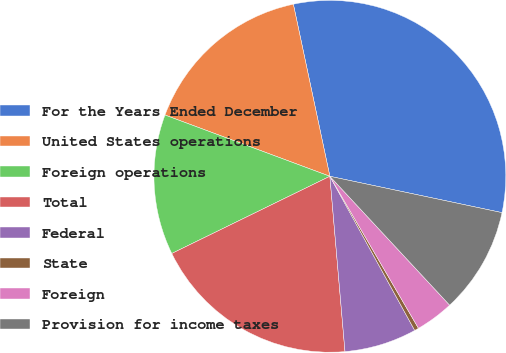Convert chart. <chart><loc_0><loc_0><loc_500><loc_500><pie_chart><fcel>For the Years Ended December<fcel>United States operations<fcel>Foreign operations<fcel>Total<fcel>Federal<fcel>State<fcel>Foreign<fcel>Provision for income taxes<nl><fcel>31.64%<fcel>16.01%<fcel>12.89%<fcel>19.14%<fcel>6.64%<fcel>0.39%<fcel>3.52%<fcel>9.77%<nl></chart> 